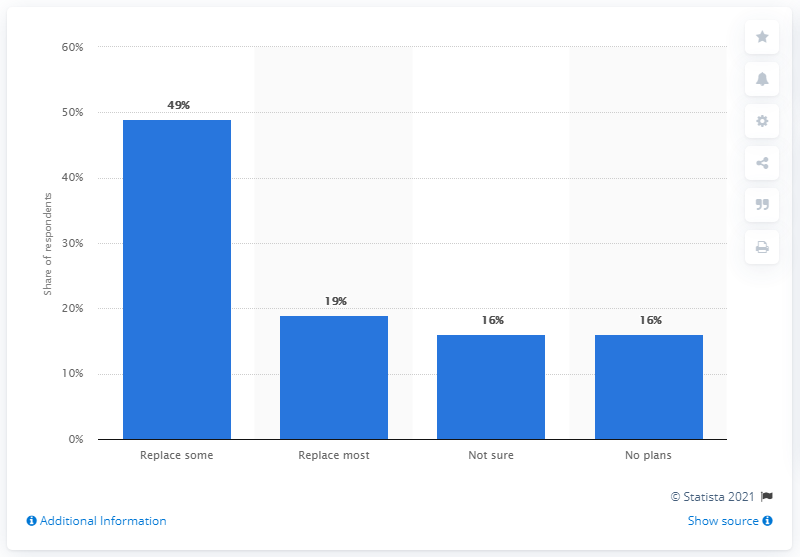Highlight a few significant elements in this photo. Nineteen percent of B2B marketers decided to replace live events with webinars. 